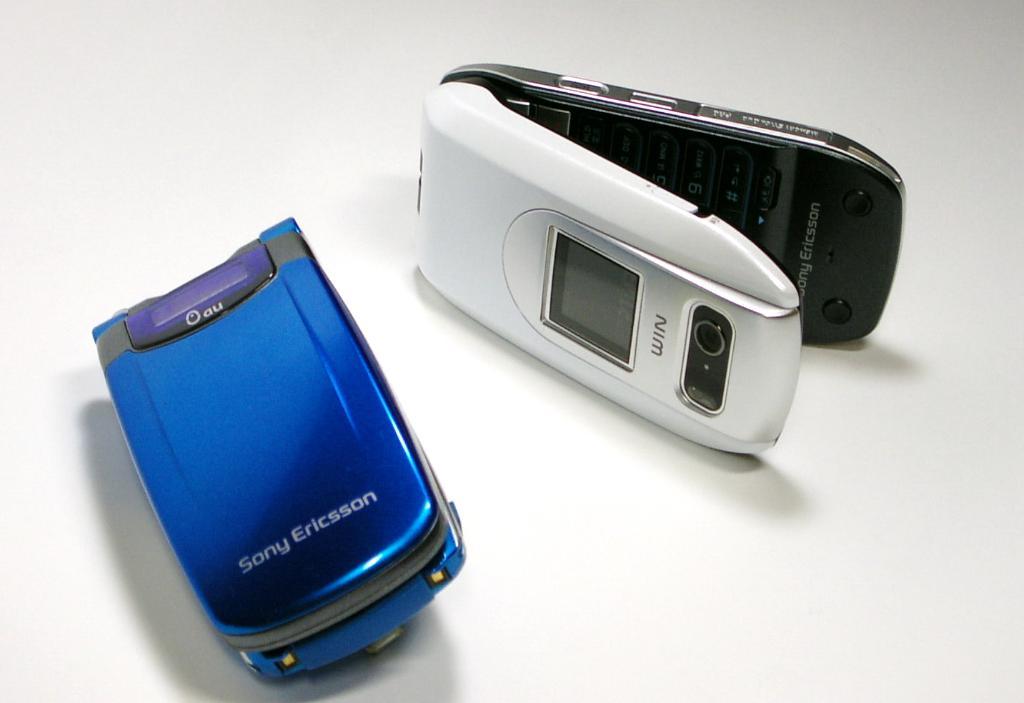What kind of phone is this?
Offer a very short reply. Sony ericsson. What is the brand of the blue flip phone?
Provide a succinct answer. Sony ericsson. 